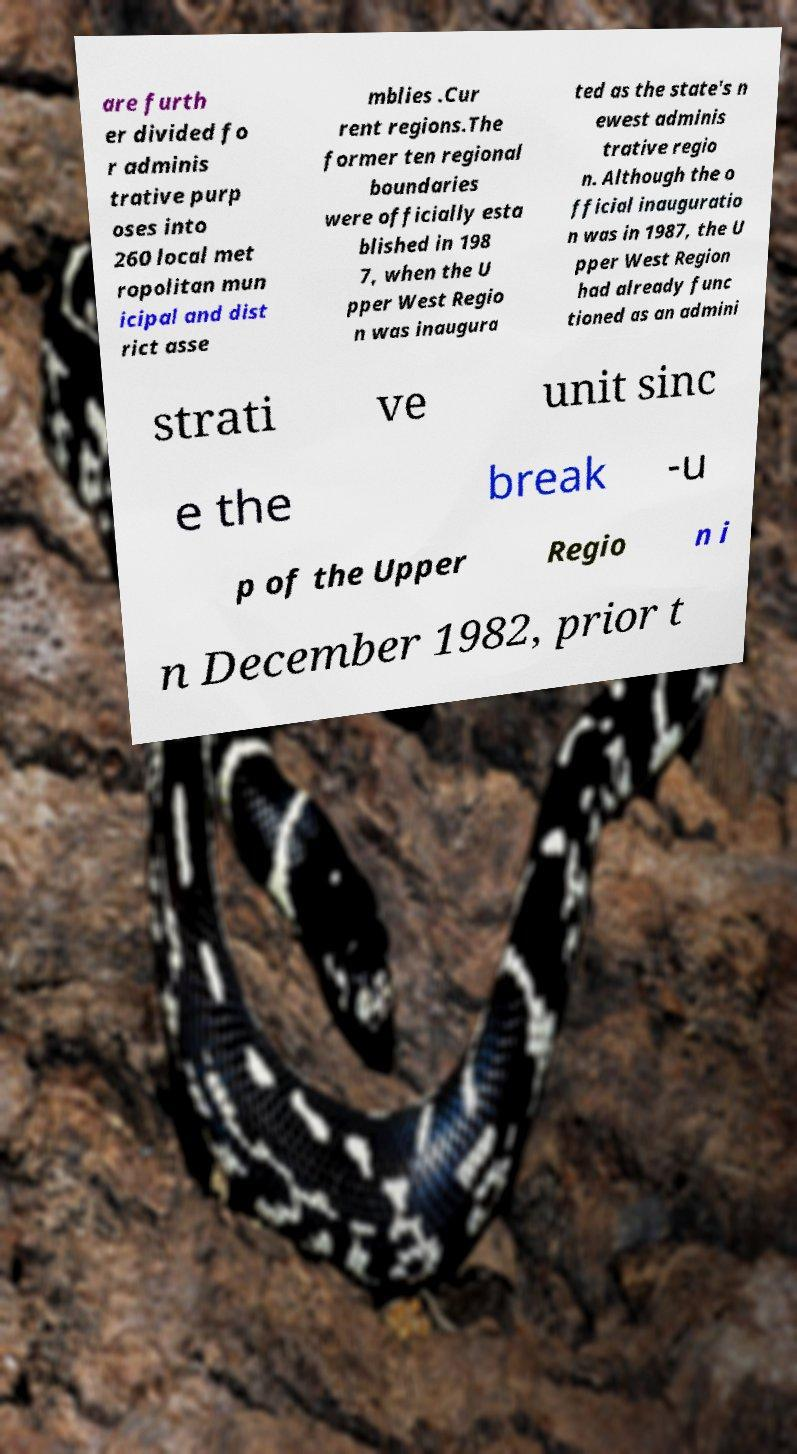What messages or text are displayed in this image? I need them in a readable, typed format. are furth er divided fo r adminis trative purp oses into 260 local met ropolitan mun icipal and dist rict asse mblies .Cur rent regions.The former ten regional boundaries were officially esta blished in 198 7, when the U pper West Regio n was inaugura ted as the state's n ewest adminis trative regio n. Although the o fficial inauguratio n was in 1987, the U pper West Region had already func tioned as an admini strati ve unit sinc e the break -u p of the Upper Regio n i n December 1982, prior t 